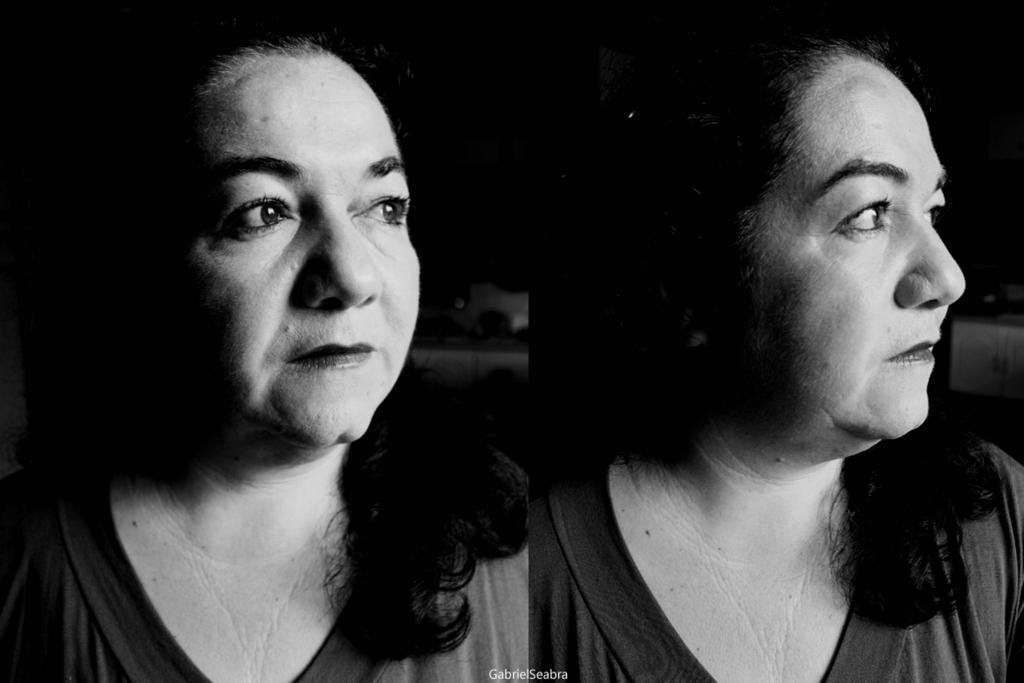Who is present in the image? There is a woman in the image. What type of image is it? The image is a collage. What color scheme is used in the image? The image is black and white in color. What type of ornament is hanging from the woman's neck in the image? There is no ornament visible around the woman's neck in the image, as it is a black and white collage. What caption is written below the image? There is no caption present below the image, as it is a collage. 